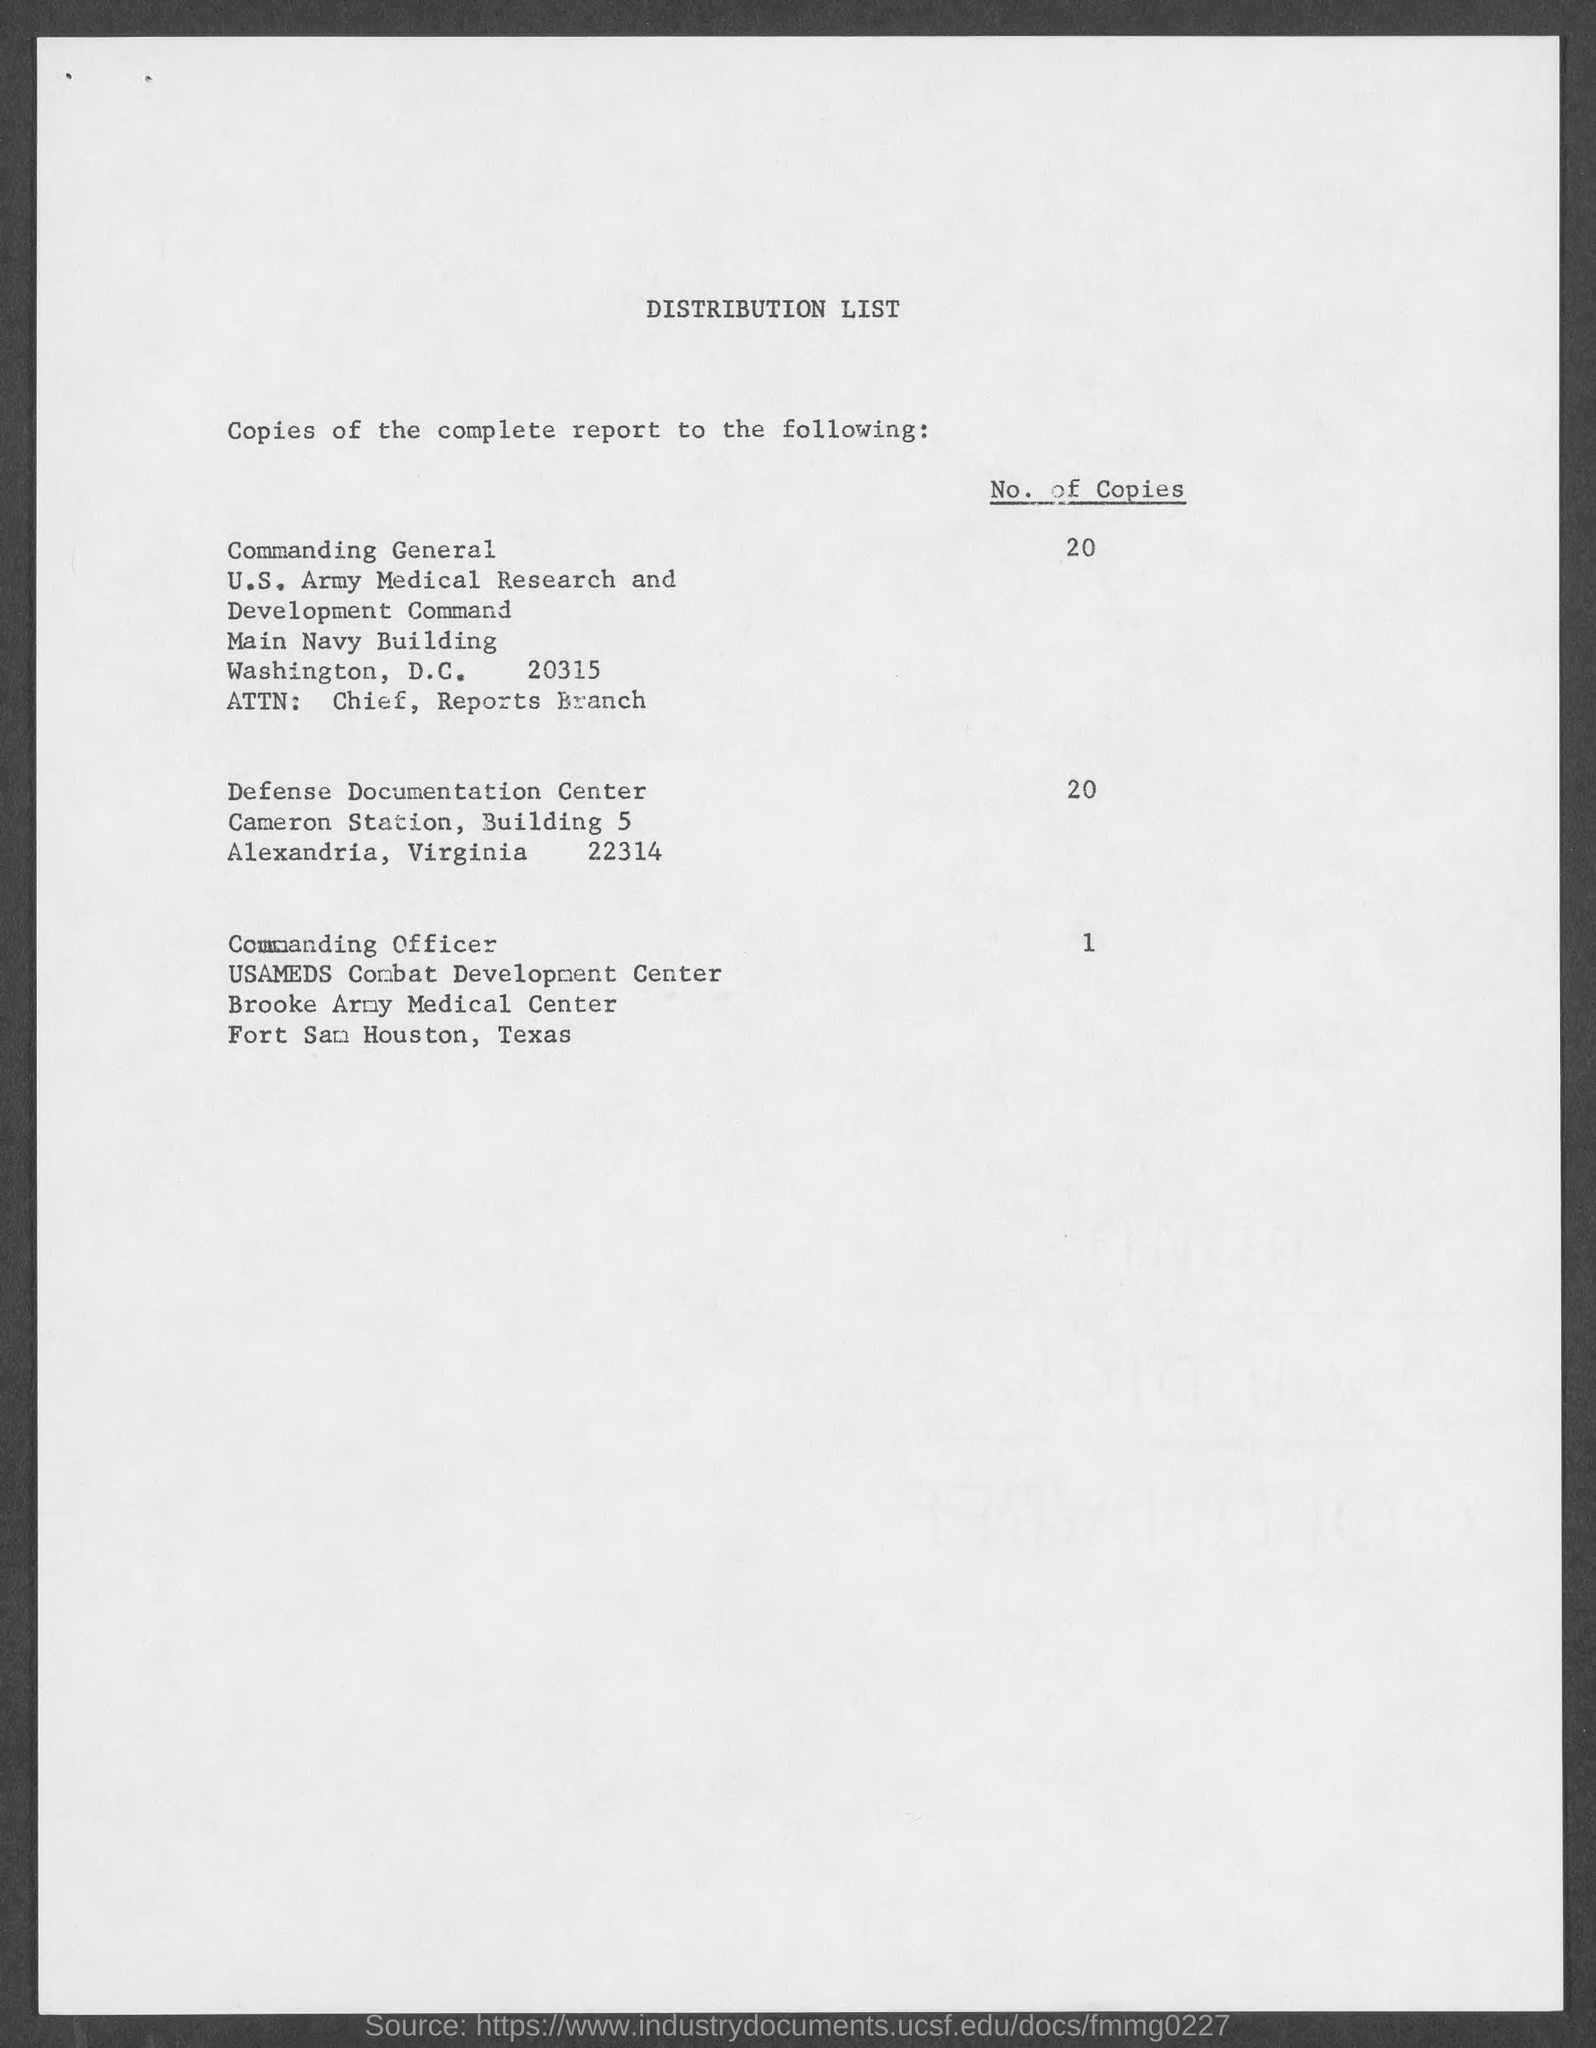What is the highest number of copies ordered and to which location are they being sent? The highest number of copies ordered is 20. This quantity is sent to both the Commanding General of the U.S. Army Medical Research and Development Command in Washington, D.C., and the Defense Documentation Center in Alexandria, Virginia. 